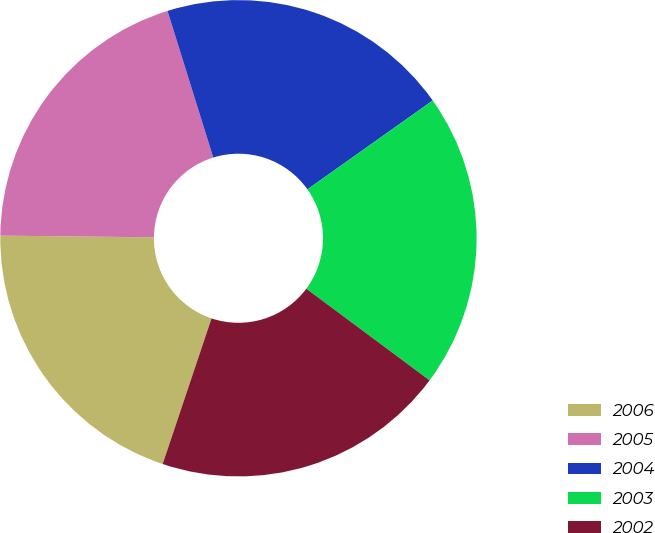<chart> <loc_0><loc_0><loc_500><loc_500><pie_chart><fcel>2006<fcel>2005<fcel>2004<fcel>2003<fcel>2002<nl><fcel>20.02%<fcel>20.01%<fcel>20.0%<fcel>19.99%<fcel>19.98%<nl></chart> 